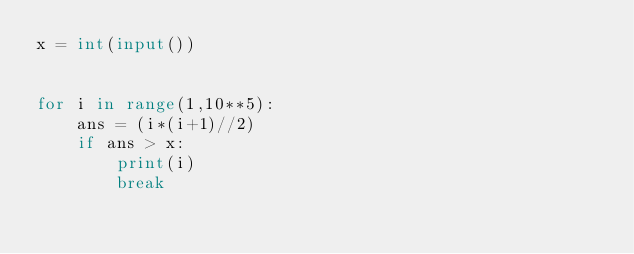<code> <loc_0><loc_0><loc_500><loc_500><_Python_>x = int(input())


for i in range(1,10**5):
    ans = (i*(i+1)//2)
    if ans > x:
        print(i)
        break</code> 